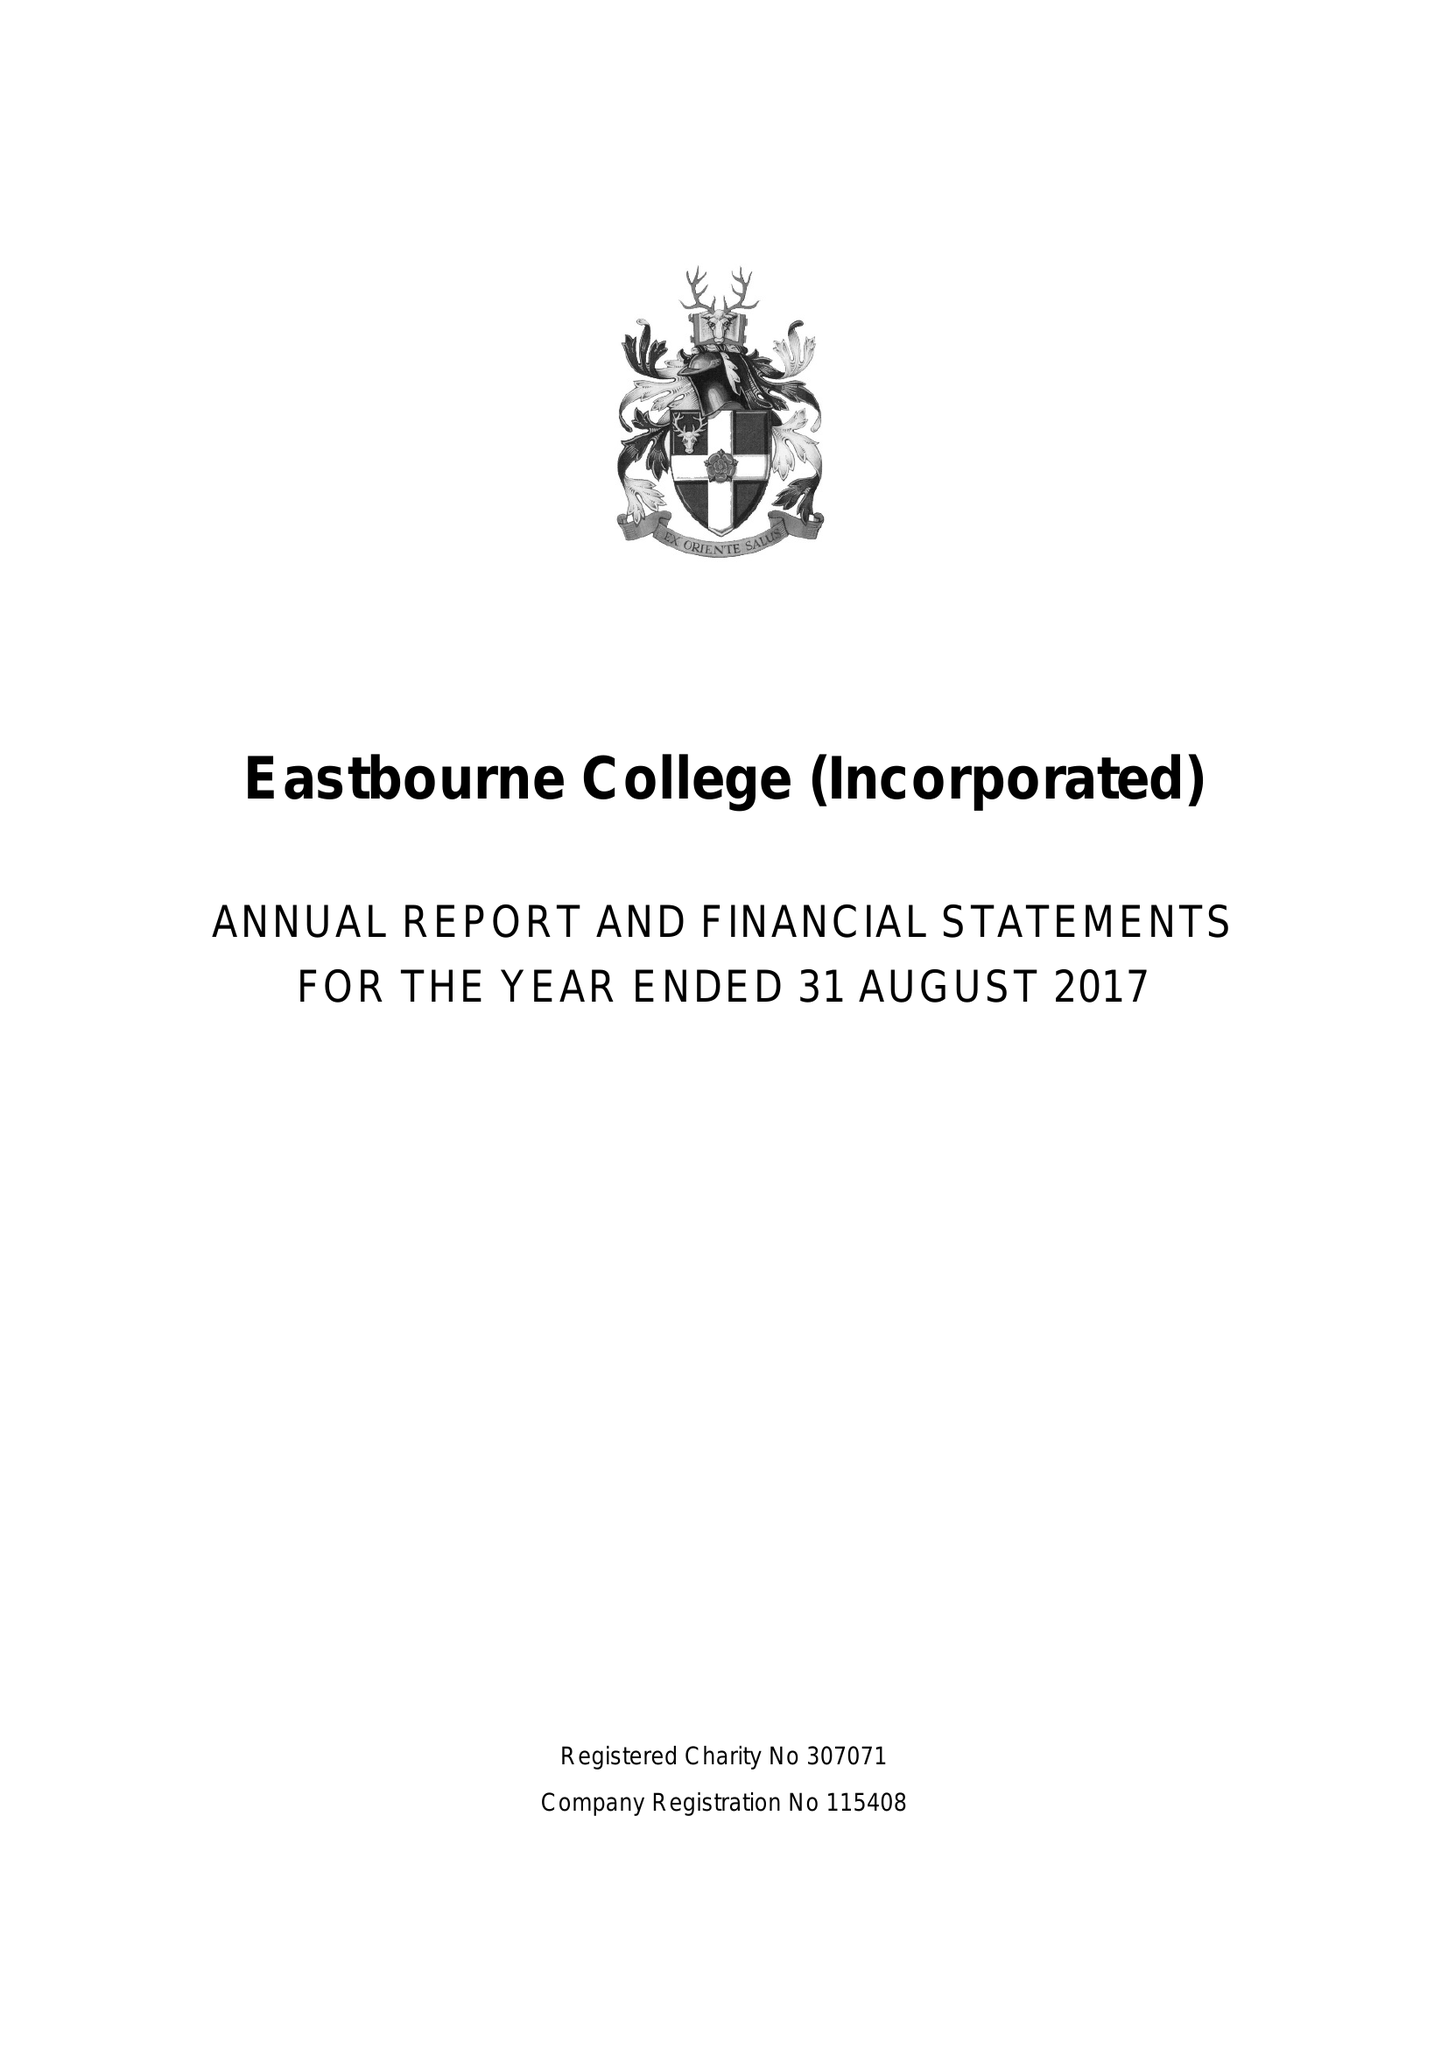What is the value for the address__street_line?
Answer the question using a single word or phrase. OLD WISH ROAD 